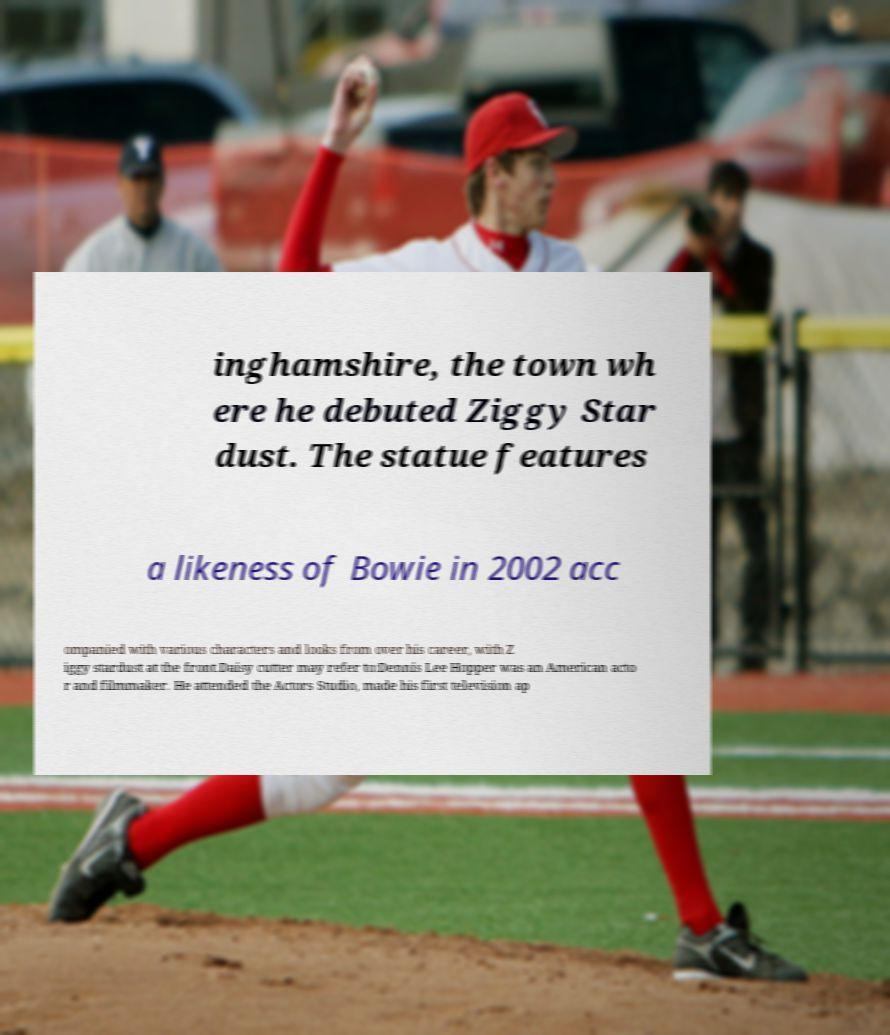I need the written content from this picture converted into text. Can you do that? inghamshire, the town wh ere he debuted Ziggy Star dust. The statue features a likeness of Bowie in 2002 acc ompanied with various characters and looks from over his career, with Z iggy stardust at the front.Daisy cutter may refer to:Dennis Lee Hopper was an American acto r and filmmaker. He attended the Actors Studio, made his first television ap 